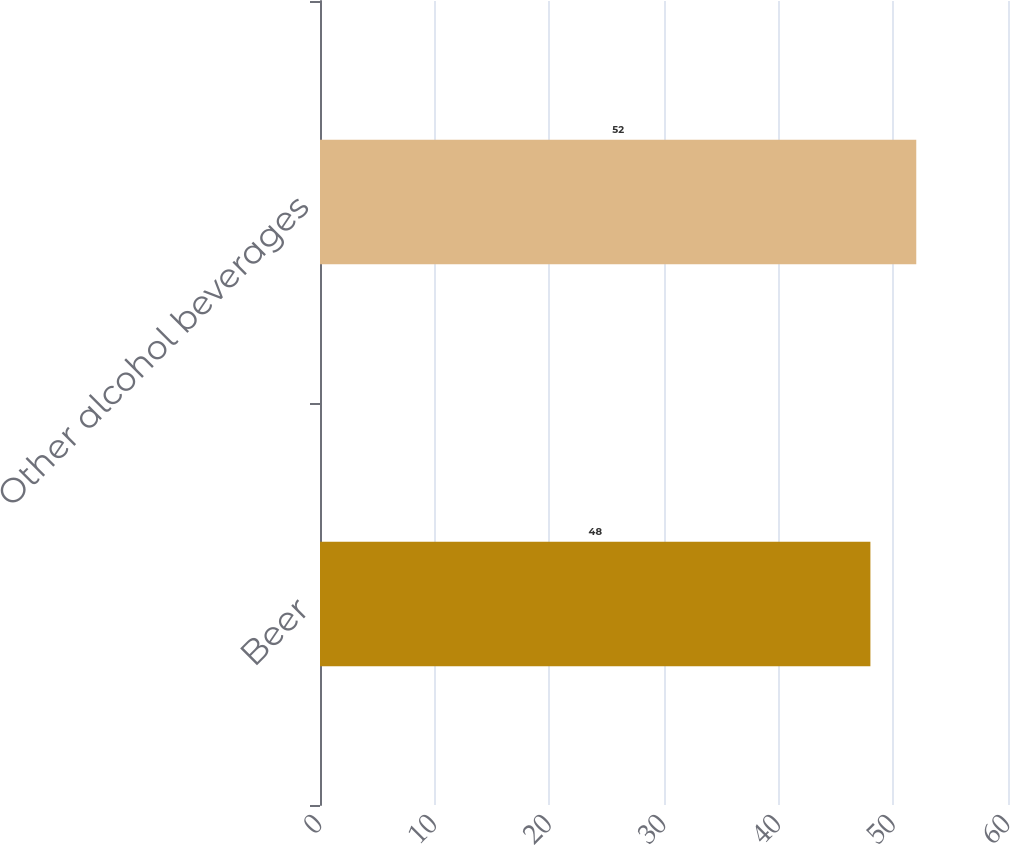Convert chart. <chart><loc_0><loc_0><loc_500><loc_500><bar_chart><fcel>Beer<fcel>Other alcohol beverages<nl><fcel>48<fcel>52<nl></chart> 